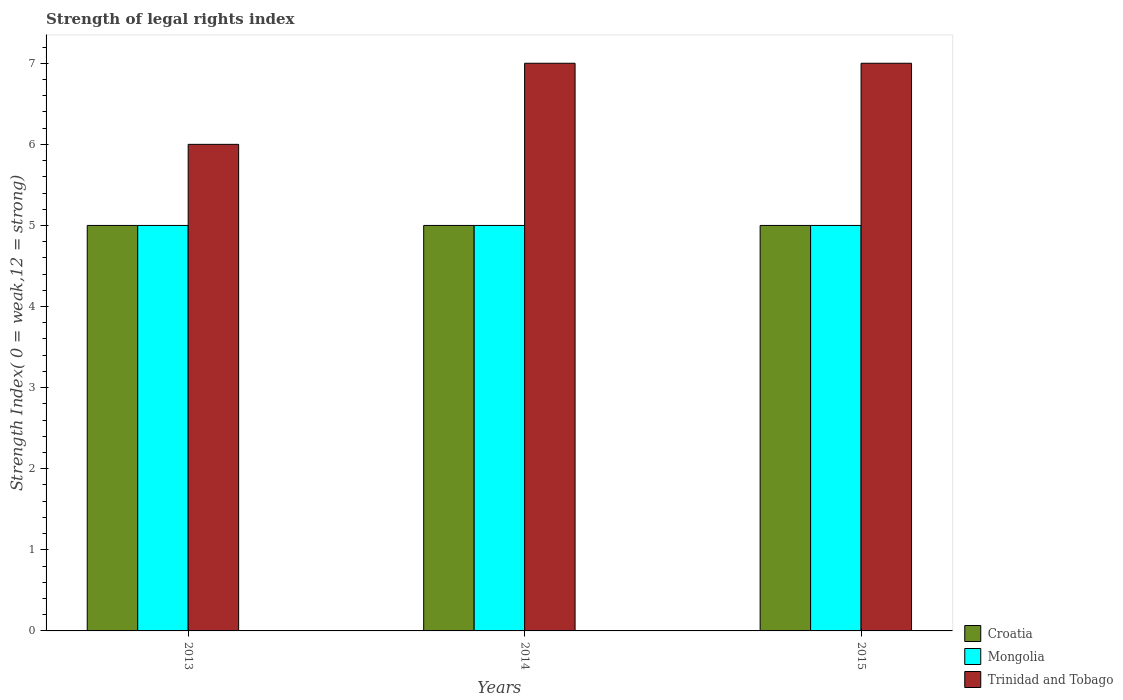Are the number of bars on each tick of the X-axis equal?
Make the answer very short. Yes. How many bars are there on the 2nd tick from the left?
Keep it short and to the point. 3. How many bars are there on the 3rd tick from the right?
Your answer should be very brief. 3. In how many cases, is the number of bars for a given year not equal to the number of legend labels?
Your response must be concise. 0. What is the strength index in Mongolia in 2013?
Ensure brevity in your answer.  5. Across all years, what is the maximum strength index in Mongolia?
Offer a very short reply. 5. Across all years, what is the minimum strength index in Croatia?
Provide a short and direct response. 5. In which year was the strength index in Mongolia minimum?
Your answer should be very brief. 2013. What is the total strength index in Mongolia in the graph?
Ensure brevity in your answer.  15. What is the difference between the strength index in Croatia in 2014 and the strength index in Trinidad and Tobago in 2013?
Keep it short and to the point. -1. What is the average strength index in Trinidad and Tobago per year?
Keep it short and to the point. 6.67. In the year 2015, what is the difference between the strength index in Mongolia and strength index in Trinidad and Tobago?
Ensure brevity in your answer.  -2. In how many years, is the strength index in Croatia greater than 5.4?
Provide a succinct answer. 0. What is the ratio of the strength index in Croatia in 2013 to that in 2014?
Provide a succinct answer. 1. Is the strength index in Croatia in 2013 less than that in 2015?
Provide a succinct answer. No. What does the 2nd bar from the left in 2015 represents?
Your answer should be very brief. Mongolia. What does the 2nd bar from the right in 2015 represents?
Make the answer very short. Mongolia. Is it the case that in every year, the sum of the strength index in Mongolia and strength index in Croatia is greater than the strength index in Trinidad and Tobago?
Provide a short and direct response. Yes. How many bars are there?
Ensure brevity in your answer.  9. Does the graph contain any zero values?
Your response must be concise. No. Where does the legend appear in the graph?
Your response must be concise. Bottom right. How are the legend labels stacked?
Ensure brevity in your answer.  Vertical. What is the title of the graph?
Give a very brief answer. Strength of legal rights index. What is the label or title of the Y-axis?
Keep it short and to the point. Strength Index( 0 = weak,12 = strong). What is the Strength Index( 0 = weak,12 = strong) of Croatia in 2013?
Keep it short and to the point. 5. What is the Strength Index( 0 = weak,12 = strong) in Trinidad and Tobago in 2013?
Your answer should be compact. 6. What is the Strength Index( 0 = weak,12 = strong) in Mongolia in 2014?
Give a very brief answer. 5. What is the Strength Index( 0 = weak,12 = strong) of Trinidad and Tobago in 2014?
Your answer should be compact. 7. What is the Strength Index( 0 = weak,12 = strong) of Mongolia in 2015?
Provide a short and direct response. 5. What is the Strength Index( 0 = weak,12 = strong) in Trinidad and Tobago in 2015?
Make the answer very short. 7. Across all years, what is the maximum Strength Index( 0 = weak,12 = strong) in Croatia?
Make the answer very short. 5. Across all years, what is the minimum Strength Index( 0 = weak,12 = strong) of Croatia?
Provide a succinct answer. 5. Across all years, what is the minimum Strength Index( 0 = weak,12 = strong) in Trinidad and Tobago?
Your answer should be compact. 6. What is the total Strength Index( 0 = weak,12 = strong) of Trinidad and Tobago in the graph?
Make the answer very short. 20. What is the difference between the Strength Index( 0 = weak,12 = strong) in Mongolia in 2013 and that in 2014?
Provide a short and direct response. 0. What is the difference between the Strength Index( 0 = weak,12 = strong) in Croatia in 2013 and that in 2015?
Your answer should be very brief. 0. What is the difference between the Strength Index( 0 = weak,12 = strong) in Mongolia in 2013 and that in 2015?
Your answer should be compact. 0. What is the difference between the Strength Index( 0 = weak,12 = strong) in Croatia in 2013 and the Strength Index( 0 = weak,12 = strong) in Trinidad and Tobago in 2014?
Your answer should be very brief. -2. What is the difference between the Strength Index( 0 = weak,12 = strong) of Mongolia in 2013 and the Strength Index( 0 = weak,12 = strong) of Trinidad and Tobago in 2014?
Make the answer very short. -2. What is the difference between the Strength Index( 0 = weak,12 = strong) in Croatia in 2013 and the Strength Index( 0 = weak,12 = strong) in Trinidad and Tobago in 2015?
Offer a terse response. -2. What is the difference between the Strength Index( 0 = weak,12 = strong) in Croatia in 2014 and the Strength Index( 0 = weak,12 = strong) in Mongolia in 2015?
Offer a very short reply. 0. What is the difference between the Strength Index( 0 = weak,12 = strong) in Croatia in 2014 and the Strength Index( 0 = weak,12 = strong) in Trinidad and Tobago in 2015?
Keep it short and to the point. -2. What is the average Strength Index( 0 = weak,12 = strong) in Mongolia per year?
Your answer should be compact. 5. What is the average Strength Index( 0 = weak,12 = strong) in Trinidad and Tobago per year?
Make the answer very short. 6.67. In the year 2013, what is the difference between the Strength Index( 0 = weak,12 = strong) of Croatia and Strength Index( 0 = weak,12 = strong) of Mongolia?
Provide a short and direct response. 0. In the year 2013, what is the difference between the Strength Index( 0 = weak,12 = strong) in Croatia and Strength Index( 0 = weak,12 = strong) in Trinidad and Tobago?
Give a very brief answer. -1. In the year 2013, what is the difference between the Strength Index( 0 = weak,12 = strong) in Mongolia and Strength Index( 0 = weak,12 = strong) in Trinidad and Tobago?
Your answer should be compact. -1. In the year 2014, what is the difference between the Strength Index( 0 = weak,12 = strong) in Croatia and Strength Index( 0 = weak,12 = strong) in Trinidad and Tobago?
Give a very brief answer. -2. In the year 2015, what is the difference between the Strength Index( 0 = weak,12 = strong) in Croatia and Strength Index( 0 = weak,12 = strong) in Mongolia?
Make the answer very short. 0. In the year 2015, what is the difference between the Strength Index( 0 = weak,12 = strong) in Mongolia and Strength Index( 0 = weak,12 = strong) in Trinidad and Tobago?
Your answer should be compact. -2. What is the ratio of the Strength Index( 0 = weak,12 = strong) of Mongolia in 2013 to that in 2014?
Keep it short and to the point. 1. What is the ratio of the Strength Index( 0 = weak,12 = strong) in Trinidad and Tobago in 2013 to that in 2014?
Keep it short and to the point. 0.86. What is the ratio of the Strength Index( 0 = weak,12 = strong) in Croatia in 2013 to that in 2015?
Keep it short and to the point. 1. What is the ratio of the Strength Index( 0 = weak,12 = strong) in Trinidad and Tobago in 2013 to that in 2015?
Give a very brief answer. 0.86. What is the ratio of the Strength Index( 0 = weak,12 = strong) in Mongolia in 2014 to that in 2015?
Keep it short and to the point. 1. What is the difference between the highest and the second highest Strength Index( 0 = weak,12 = strong) in Mongolia?
Ensure brevity in your answer.  0. What is the difference between the highest and the second highest Strength Index( 0 = weak,12 = strong) of Trinidad and Tobago?
Provide a succinct answer. 0. What is the difference between the highest and the lowest Strength Index( 0 = weak,12 = strong) of Mongolia?
Make the answer very short. 0. 